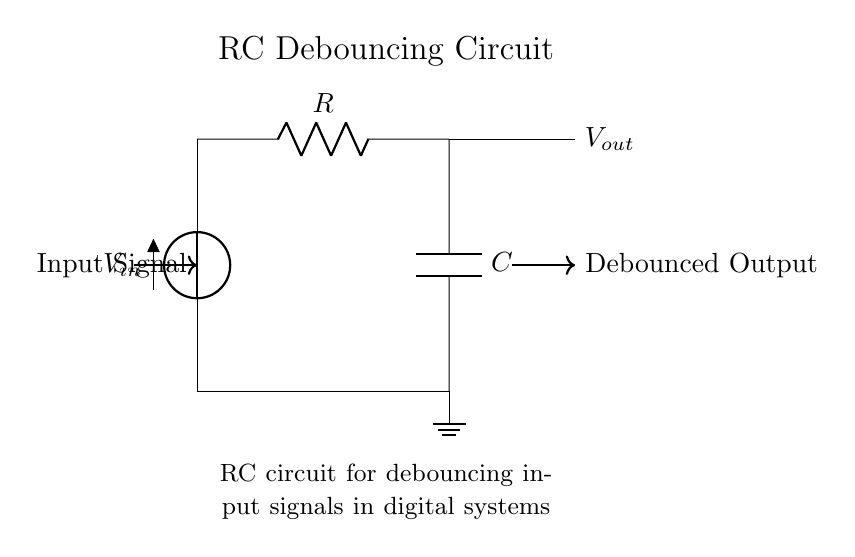What are the components used in this circuit? The circuit contains a voltage source, a resistor, and a capacitor. These three components are standard in RC circuits for debouncing signals.
Answer: voltage source, resistor, capacitor What is the purpose of the capacitor in this circuit? The capacitor is used to store charge and smooth out the output signal by filtering out high-frequency noise, which effectively debounces the input signal in digital systems.
Answer: smooth output signal What is the function of the resistor in this circuit? The resistor limits the current flowing to the capacitor and controls the charging and discharging timing, thus helping to set the debounce time constant of the circuit.
Answer: limit current What is the output of this circuit after debouncing? The output represents a cleaner, stable signal that corresponds to the intended input signal without the noise created by mechanical bouncing.
Answer: debounced output What is the time constant formula for this RC circuit? The time constant is determined by the product of resistance and capacitance, calculated as tau equals the resistor value multiplied by the capacitor value (tau equals R times C).
Answer: tau equals R times C How does changing the resistor value affect the debounce time? Increasing the resistor value increases the time constant, which results in a longer debounce time, allowing the capacitor to charge or discharge more slowly and filtering out bouncing for a longer period.
Answer: longer debounce time 